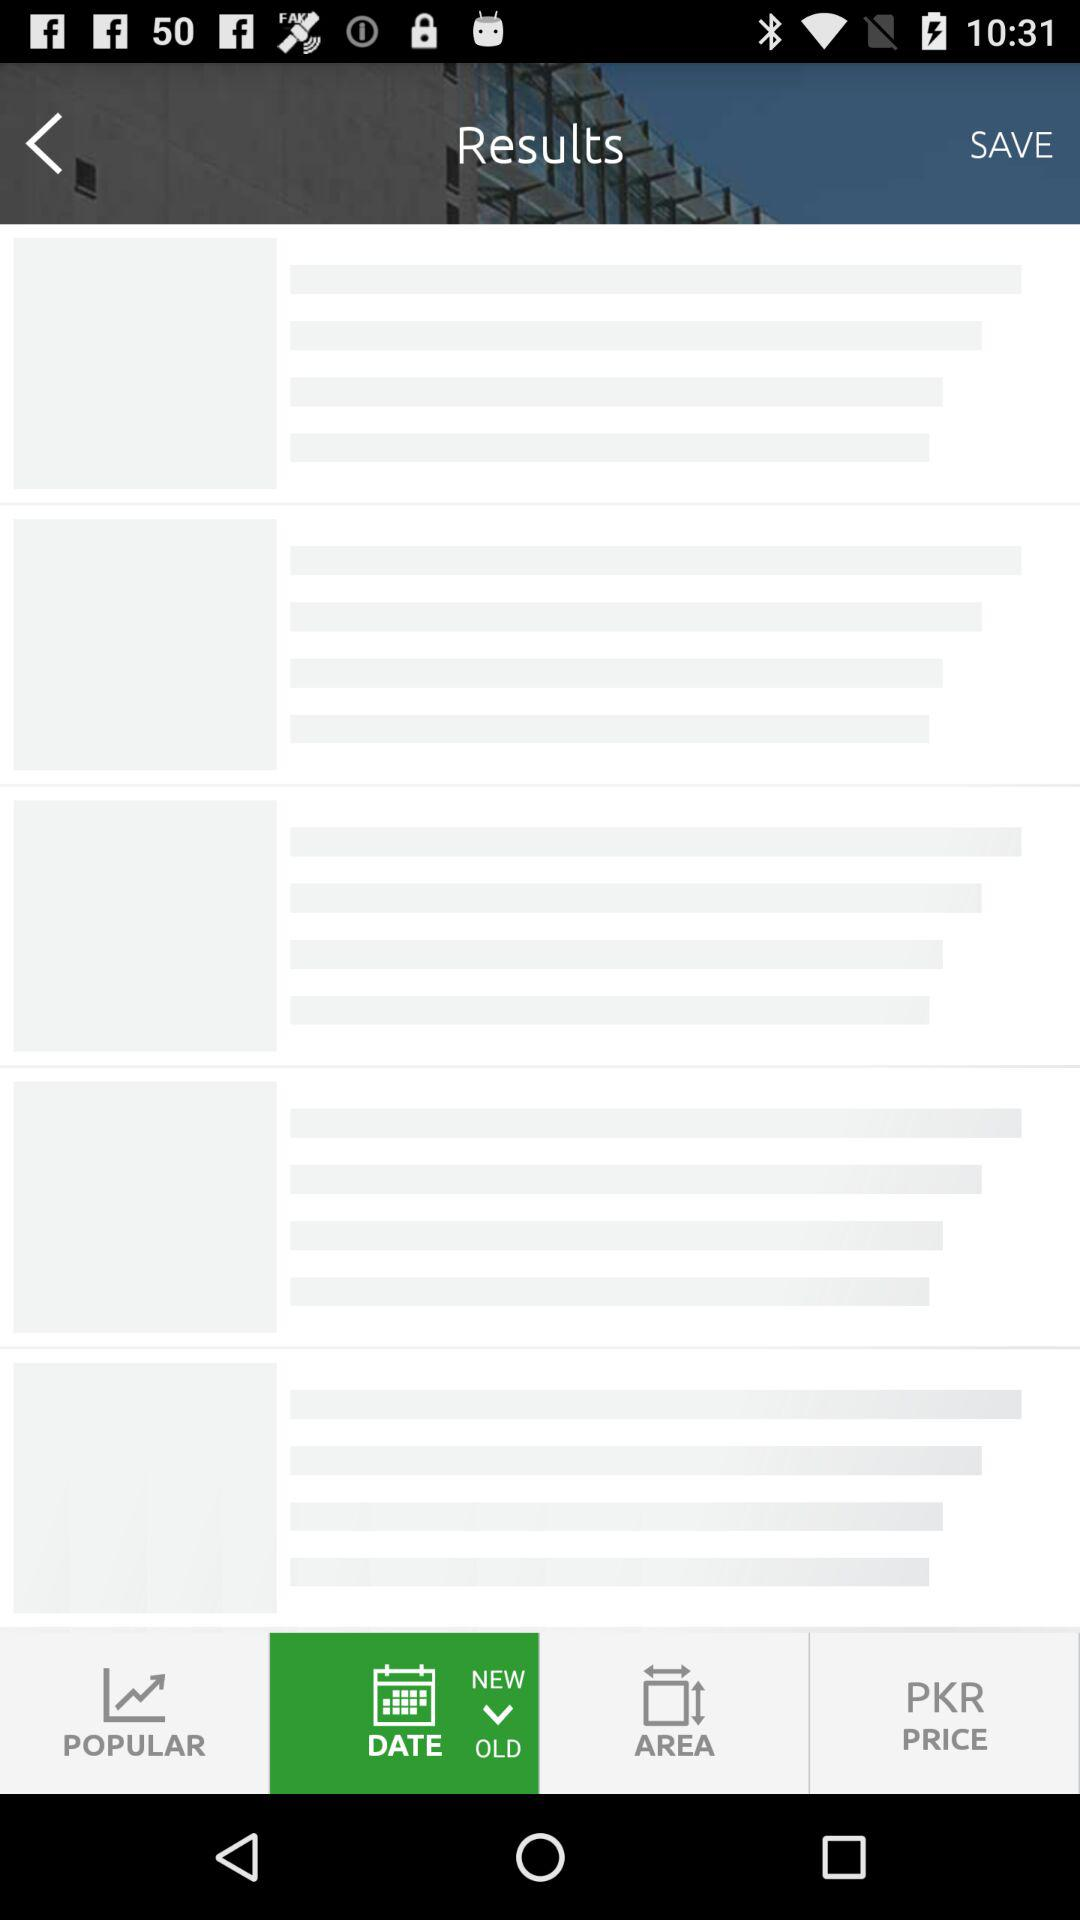What is the count of beds and baths? The count of beds is 5 and the count of baths is 6. 